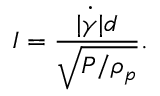<formula> <loc_0><loc_0><loc_500><loc_500>I = \frac { \dot { | \gamma | } d } { \sqrt { P / \rho _ { p } } } .</formula> 